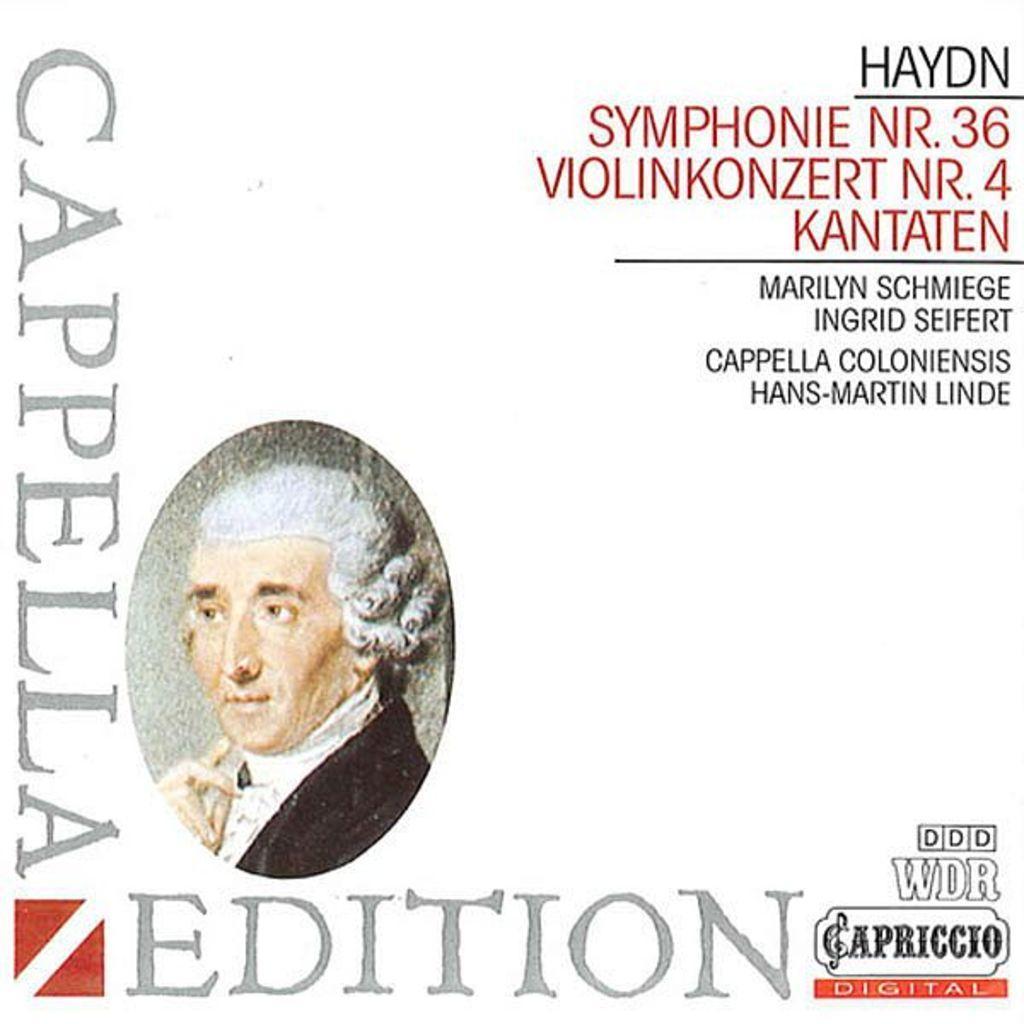Describe this image in one or two sentences. This image is a painting on the book. In this image, on the left side, we can see a painting of a person. On the right side, we can see some text written on the book. 